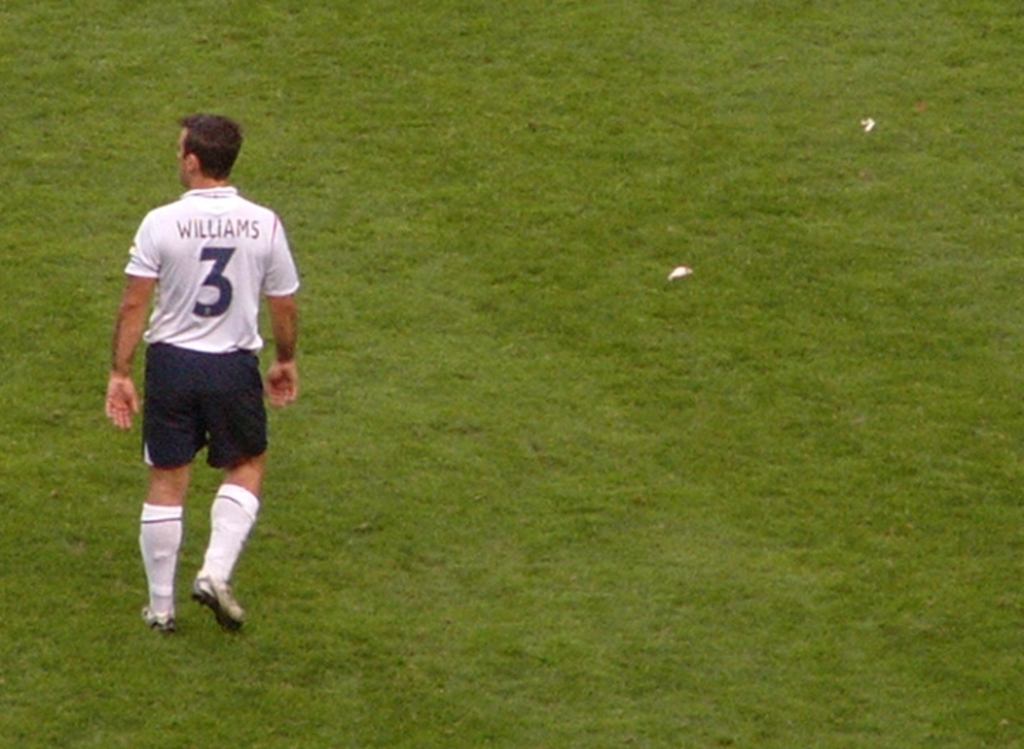Provide a one-sentence caption for the provided image. A football player named 'Williams,' wearing jersey number 3, strides across the lush soccer field during a pause in the game. 